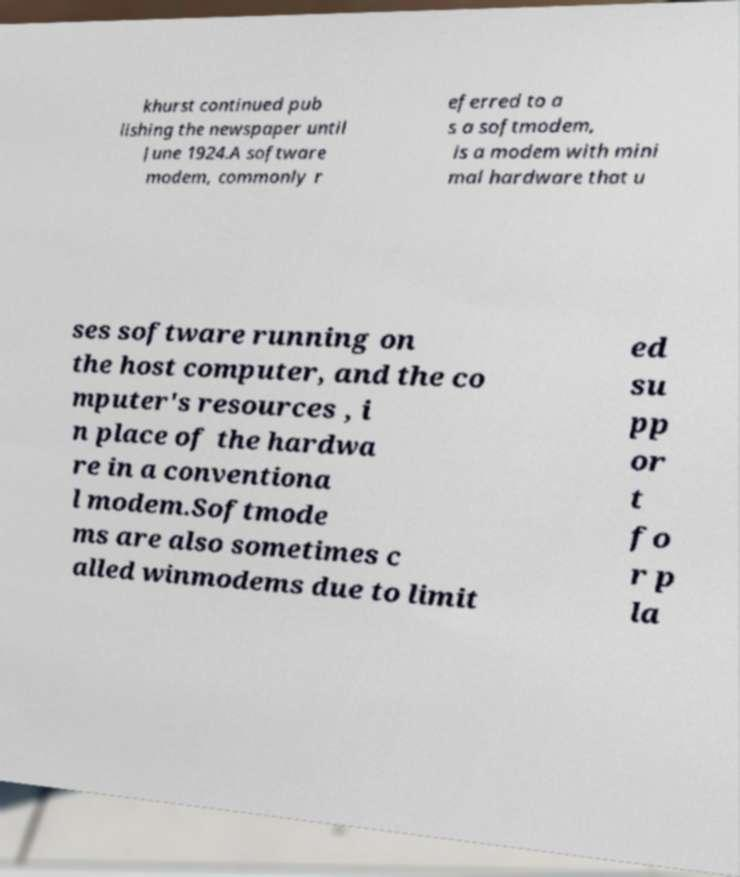For documentation purposes, I need the text within this image transcribed. Could you provide that? khurst continued pub lishing the newspaper until June 1924.A software modem, commonly r eferred to a s a softmodem, is a modem with mini mal hardware that u ses software running on the host computer, and the co mputer's resources , i n place of the hardwa re in a conventiona l modem.Softmode ms are also sometimes c alled winmodems due to limit ed su pp or t fo r p la 